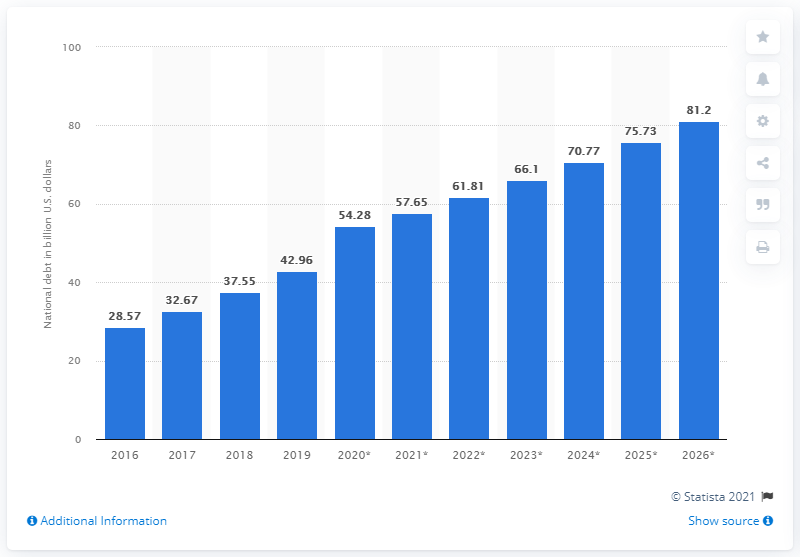Point out several critical features in this image. The national debt of the Dominican Republic in 2019 was 42.96 dollars. 